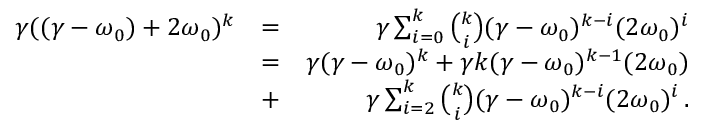<formula> <loc_0><loc_0><loc_500><loc_500>\begin{array} { r l r } { \gamma ( ( \gamma - \omega _ { 0 } ) + 2 \omega _ { 0 } ) ^ { k } } & { = } & { \gamma \sum _ { i = 0 } ^ { k } \binom { k } { i } ( \gamma - \omega _ { 0 } ) ^ { k - i } ( 2 \omega _ { 0 } ) ^ { i } } \\ & { = } & { \gamma ( \gamma - \omega _ { 0 } ) ^ { k } + \gamma k ( \gamma - \omega _ { 0 } ) ^ { k - 1 } ( 2 \omega _ { 0 } ) } \\ & { + } & { \gamma \sum _ { i = 2 } ^ { k } \binom { k } { i } ( \gamma - \omega _ { 0 } ) ^ { k - i } ( 2 \omega _ { 0 } ) ^ { i } \, . } \end{array}</formula> 